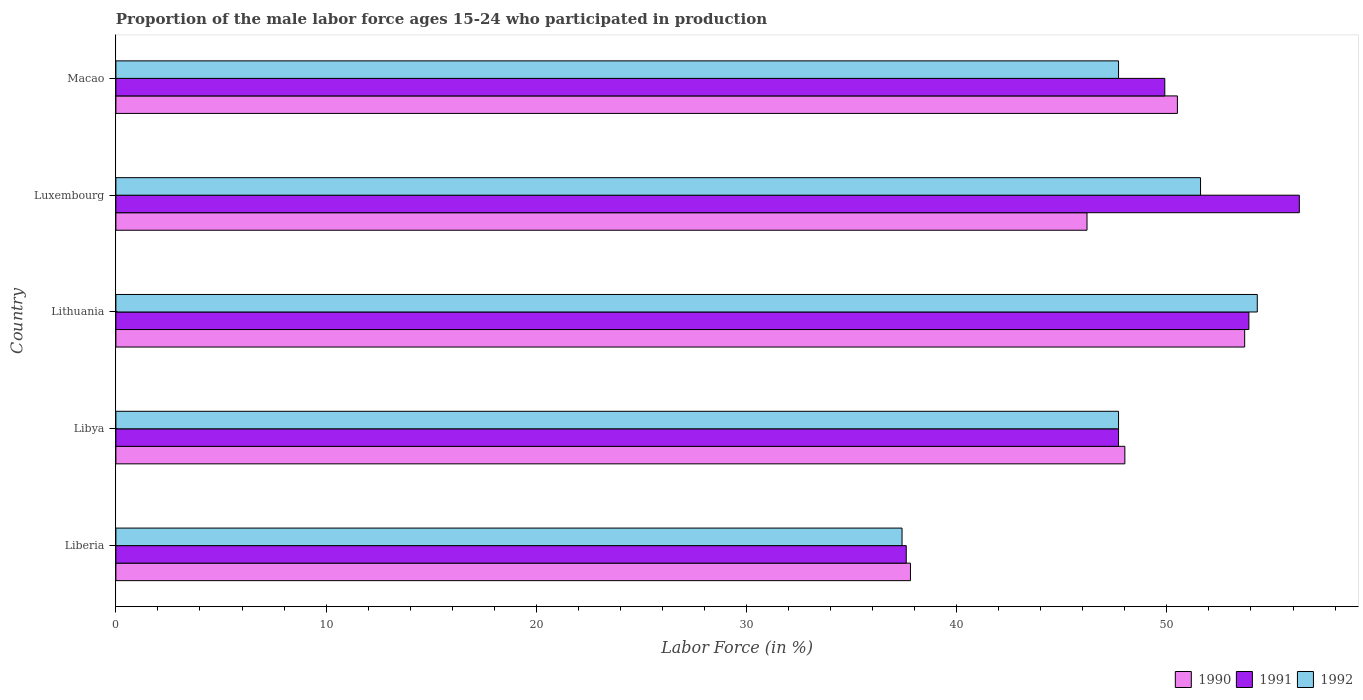Are the number of bars on each tick of the Y-axis equal?
Ensure brevity in your answer.  Yes. How many bars are there on the 5th tick from the bottom?
Offer a very short reply. 3. What is the label of the 1st group of bars from the top?
Provide a succinct answer. Macao. In how many cases, is the number of bars for a given country not equal to the number of legend labels?
Give a very brief answer. 0. What is the proportion of the male labor force who participated in production in 1991 in Luxembourg?
Give a very brief answer. 56.3. Across all countries, what is the maximum proportion of the male labor force who participated in production in 1991?
Your answer should be compact. 56.3. Across all countries, what is the minimum proportion of the male labor force who participated in production in 1990?
Offer a very short reply. 37.8. In which country was the proportion of the male labor force who participated in production in 1992 maximum?
Ensure brevity in your answer.  Lithuania. In which country was the proportion of the male labor force who participated in production in 1990 minimum?
Your response must be concise. Liberia. What is the total proportion of the male labor force who participated in production in 1990 in the graph?
Offer a very short reply. 236.2. What is the difference between the proportion of the male labor force who participated in production in 1990 in Liberia and that in Lithuania?
Your response must be concise. -15.9. What is the difference between the proportion of the male labor force who participated in production in 1991 in Macao and the proportion of the male labor force who participated in production in 1992 in Lithuania?
Provide a succinct answer. -4.4. What is the average proportion of the male labor force who participated in production in 1992 per country?
Keep it short and to the point. 47.74. What is the difference between the proportion of the male labor force who participated in production in 1991 and proportion of the male labor force who participated in production in 1990 in Luxembourg?
Your response must be concise. 10.1. In how many countries, is the proportion of the male labor force who participated in production in 1990 greater than 42 %?
Your answer should be very brief. 4. What is the ratio of the proportion of the male labor force who participated in production in 1990 in Liberia to that in Lithuania?
Provide a succinct answer. 0.7. What is the difference between the highest and the second highest proportion of the male labor force who participated in production in 1991?
Keep it short and to the point. 2.4. What is the difference between the highest and the lowest proportion of the male labor force who participated in production in 1990?
Keep it short and to the point. 15.9. In how many countries, is the proportion of the male labor force who participated in production in 1991 greater than the average proportion of the male labor force who participated in production in 1991 taken over all countries?
Provide a short and direct response. 3. Is the sum of the proportion of the male labor force who participated in production in 1992 in Libya and Lithuania greater than the maximum proportion of the male labor force who participated in production in 1991 across all countries?
Keep it short and to the point. Yes. What does the 2nd bar from the top in Liberia represents?
Make the answer very short. 1991. What does the 3rd bar from the bottom in Lithuania represents?
Your answer should be very brief. 1992. Are all the bars in the graph horizontal?
Give a very brief answer. Yes. How many countries are there in the graph?
Make the answer very short. 5. Does the graph contain any zero values?
Your answer should be very brief. No. Does the graph contain grids?
Make the answer very short. No. Where does the legend appear in the graph?
Provide a short and direct response. Bottom right. How many legend labels are there?
Make the answer very short. 3. What is the title of the graph?
Provide a short and direct response. Proportion of the male labor force ages 15-24 who participated in production. Does "1976" appear as one of the legend labels in the graph?
Ensure brevity in your answer.  No. What is the label or title of the X-axis?
Your answer should be very brief. Labor Force (in %). What is the Labor Force (in %) in 1990 in Liberia?
Your response must be concise. 37.8. What is the Labor Force (in %) of 1991 in Liberia?
Your response must be concise. 37.6. What is the Labor Force (in %) in 1992 in Liberia?
Give a very brief answer. 37.4. What is the Labor Force (in %) of 1990 in Libya?
Your response must be concise. 48. What is the Labor Force (in %) of 1991 in Libya?
Make the answer very short. 47.7. What is the Labor Force (in %) of 1992 in Libya?
Make the answer very short. 47.7. What is the Labor Force (in %) of 1990 in Lithuania?
Make the answer very short. 53.7. What is the Labor Force (in %) in 1991 in Lithuania?
Provide a succinct answer. 53.9. What is the Labor Force (in %) in 1992 in Lithuania?
Provide a short and direct response. 54.3. What is the Labor Force (in %) in 1990 in Luxembourg?
Make the answer very short. 46.2. What is the Labor Force (in %) of 1991 in Luxembourg?
Your response must be concise. 56.3. What is the Labor Force (in %) in 1992 in Luxembourg?
Provide a succinct answer. 51.6. What is the Labor Force (in %) of 1990 in Macao?
Your answer should be very brief. 50.5. What is the Labor Force (in %) of 1991 in Macao?
Offer a terse response. 49.9. What is the Labor Force (in %) of 1992 in Macao?
Offer a terse response. 47.7. Across all countries, what is the maximum Labor Force (in %) in 1990?
Provide a short and direct response. 53.7. Across all countries, what is the maximum Labor Force (in %) in 1991?
Ensure brevity in your answer.  56.3. Across all countries, what is the maximum Labor Force (in %) in 1992?
Provide a succinct answer. 54.3. Across all countries, what is the minimum Labor Force (in %) of 1990?
Give a very brief answer. 37.8. Across all countries, what is the minimum Labor Force (in %) in 1991?
Offer a terse response. 37.6. Across all countries, what is the minimum Labor Force (in %) of 1992?
Your answer should be very brief. 37.4. What is the total Labor Force (in %) of 1990 in the graph?
Make the answer very short. 236.2. What is the total Labor Force (in %) in 1991 in the graph?
Your answer should be very brief. 245.4. What is the total Labor Force (in %) of 1992 in the graph?
Your answer should be compact. 238.7. What is the difference between the Labor Force (in %) in 1990 in Liberia and that in Libya?
Offer a very short reply. -10.2. What is the difference between the Labor Force (in %) in 1992 in Liberia and that in Libya?
Offer a terse response. -10.3. What is the difference between the Labor Force (in %) in 1990 in Liberia and that in Lithuania?
Ensure brevity in your answer.  -15.9. What is the difference between the Labor Force (in %) of 1991 in Liberia and that in Lithuania?
Make the answer very short. -16.3. What is the difference between the Labor Force (in %) of 1992 in Liberia and that in Lithuania?
Ensure brevity in your answer.  -16.9. What is the difference between the Labor Force (in %) in 1990 in Liberia and that in Luxembourg?
Your answer should be compact. -8.4. What is the difference between the Labor Force (in %) of 1991 in Liberia and that in Luxembourg?
Keep it short and to the point. -18.7. What is the difference between the Labor Force (in %) of 1992 in Liberia and that in Luxembourg?
Your answer should be very brief. -14.2. What is the difference between the Labor Force (in %) of 1990 in Liberia and that in Macao?
Offer a terse response. -12.7. What is the difference between the Labor Force (in %) in 1991 in Liberia and that in Macao?
Make the answer very short. -12.3. What is the difference between the Labor Force (in %) of 1990 in Libya and that in Lithuania?
Provide a short and direct response. -5.7. What is the difference between the Labor Force (in %) in 1992 in Libya and that in Lithuania?
Your response must be concise. -6.6. What is the difference between the Labor Force (in %) of 1990 in Libya and that in Luxembourg?
Provide a short and direct response. 1.8. What is the difference between the Labor Force (in %) of 1990 in Libya and that in Macao?
Give a very brief answer. -2.5. What is the difference between the Labor Force (in %) in 1990 in Lithuania and that in Macao?
Your answer should be very brief. 3.2. What is the difference between the Labor Force (in %) in 1991 in Lithuania and that in Macao?
Offer a very short reply. 4. What is the difference between the Labor Force (in %) of 1992 in Lithuania and that in Macao?
Your answer should be compact. 6.6. What is the difference between the Labor Force (in %) of 1991 in Luxembourg and that in Macao?
Your answer should be compact. 6.4. What is the difference between the Labor Force (in %) of 1990 in Liberia and the Labor Force (in %) of 1992 in Libya?
Give a very brief answer. -9.9. What is the difference between the Labor Force (in %) of 1990 in Liberia and the Labor Force (in %) of 1991 in Lithuania?
Offer a terse response. -16.1. What is the difference between the Labor Force (in %) in 1990 in Liberia and the Labor Force (in %) in 1992 in Lithuania?
Your answer should be very brief. -16.5. What is the difference between the Labor Force (in %) in 1991 in Liberia and the Labor Force (in %) in 1992 in Lithuania?
Ensure brevity in your answer.  -16.7. What is the difference between the Labor Force (in %) of 1990 in Liberia and the Labor Force (in %) of 1991 in Luxembourg?
Offer a terse response. -18.5. What is the difference between the Labor Force (in %) of 1990 in Liberia and the Labor Force (in %) of 1991 in Macao?
Your answer should be very brief. -12.1. What is the difference between the Labor Force (in %) in 1991 in Liberia and the Labor Force (in %) in 1992 in Macao?
Make the answer very short. -10.1. What is the difference between the Labor Force (in %) in 1990 in Libya and the Labor Force (in %) in 1991 in Lithuania?
Your answer should be very brief. -5.9. What is the difference between the Labor Force (in %) in 1990 in Libya and the Labor Force (in %) in 1992 in Lithuania?
Your response must be concise. -6.3. What is the difference between the Labor Force (in %) in 1991 in Libya and the Labor Force (in %) in 1992 in Lithuania?
Ensure brevity in your answer.  -6.6. What is the difference between the Labor Force (in %) of 1990 in Libya and the Labor Force (in %) of 1992 in Luxembourg?
Offer a terse response. -3.6. What is the difference between the Labor Force (in %) in 1991 in Libya and the Labor Force (in %) in 1992 in Luxembourg?
Your answer should be compact. -3.9. What is the difference between the Labor Force (in %) of 1990 in Libya and the Labor Force (in %) of 1991 in Macao?
Provide a succinct answer. -1.9. What is the difference between the Labor Force (in %) of 1991 in Libya and the Labor Force (in %) of 1992 in Macao?
Ensure brevity in your answer.  0. What is the difference between the Labor Force (in %) in 1990 in Lithuania and the Labor Force (in %) in 1991 in Luxembourg?
Your answer should be very brief. -2.6. What is the difference between the Labor Force (in %) of 1990 in Lithuania and the Labor Force (in %) of 1992 in Luxembourg?
Give a very brief answer. 2.1. What is the difference between the Labor Force (in %) of 1991 in Lithuania and the Labor Force (in %) of 1992 in Luxembourg?
Your answer should be very brief. 2.3. What is the difference between the Labor Force (in %) of 1990 in Lithuania and the Labor Force (in %) of 1991 in Macao?
Give a very brief answer. 3.8. What is the average Labor Force (in %) of 1990 per country?
Your response must be concise. 47.24. What is the average Labor Force (in %) of 1991 per country?
Your response must be concise. 49.08. What is the average Labor Force (in %) in 1992 per country?
Ensure brevity in your answer.  47.74. What is the difference between the Labor Force (in %) of 1991 and Labor Force (in %) of 1992 in Liberia?
Offer a terse response. 0.2. What is the difference between the Labor Force (in %) of 1991 and Labor Force (in %) of 1992 in Libya?
Offer a very short reply. 0. What is the difference between the Labor Force (in %) in 1991 and Labor Force (in %) in 1992 in Lithuania?
Make the answer very short. -0.4. What is the difference between the Labor Force (in %) in 1990 and Labor Force (in %) in 1992 in Luxembourg?
Offer a very short reply. -5.4. What is the difference between the Labor Force (in %) of 1991 and Labor Force (in %) of 1992 in Luxembourg?
Give a very brief answer. 4.7. What is the difference between the Labor Force (in %) in 1990 and Labor Force (in %) in 1991 in Macao?
Keep it short and to the point. 0.6. What is the difference between the Labor Force (in %) of 1990 and Labor Force (in %) of 1992 in Macao?
Make the answer very short. 2.8. What is the difference between the Labor Force (in %) of 1991 and Labor Force (in %) of 1992 in Macao?
Give a very brief answer. 2.2. What is the ratio of the Labor Force (in %) of 1990 in Liberia to that in Libya?
Keep it short and to the point. 0.79. What is the ratio of the Labor Force (in %) of 1991 in Liberia to that in Libya?
Provide a succinct answer. 0.79. What is the ratio of the Labor Force (in %) in 1992 in Liberia to that in Libya?
Offer a very short reply. 0.78. What is the ratio of the Labor Force (in %) of 1990 in Liberia to that in Lithuania?
Make the answer very short. 0.7. What is the ratio of the Labor Force (in %) in 1991 in Liberia to that in Lithuania?
Ensure brevity in your answer.  0.7. What is the ratio of the Labor Force (in %) of 1992 in Liberia to that in Lithuania?
Give a very brief answer. 0.69. What is the ratio of the Labor Force (in %) of 1990 in Liberia to that in Luxembourg?
Your response must be concise. 0.82. What is the ratio of the Labor Force (in %) in 1991 in Liberia to that in Luxembourg?
Your answer should be very brief. 0.67. What is the ratio of the Labor Force (in %) in 1992 in Liberia to that in Luxembourg?
Offer a very short reply. 0.72. What is the ratio of the Labor Force (in %) in 1990 in Liberia to that in Macao?
Keep it short and to the point. 0.75. What is the ratio of the Labor Force (in %) in 1991 in Liberia to that in Macao?
Give a very brief answer. 0.75. What is the ratio of the Labor Force (in %) in 1992 in Liberia to that in Macao?
Your answer should be compact. 0.78. What is the ratio of the Labor Force (in %) in 1990 in Libya to that in Lithuania?
Keep it short and to the point. 0.89. What is the ratio of the Labor Force (in %) of 1991 in Libya to that in Lithuania?
Offer a terse response. 0.89. What is the ratio of the Labor Force (in %) in 1992 in Libya to that in Lithuania?
Provide a succinct answer. 0.88. What is the ratio of the Labor Force (in %) of 1990 in Libya to that in Luxembourg?
Give a very brief answer. 1.04. What is the ratio of the Labor Force (in %) in 1991 in Libya to that in Luxembourg?
Provide a succinct answer. 0.85. What is the ratio of the Labor Force (in %) in 1992 in Libya to that in Luxembourg?
Give a very brief answer. 0.92. What is the ratio of the Labor Force (in %) of 1990 in Libya to that in Macao?
Your answer should be compact. 0.95. What is the ratio of the Labor Force (in %) of 1991 in Libya to that in Macao?
Offer a very short reply. 0.96. What is the ratio of the Labor Force (in %) in 1990 in Lithuania to that in Luxembourg?
Your answer should be compact. 1.16. What is the ratio of the Labor Force (in %) in 1991 in Lithuania to that in Luxembourg?
Provide a short and direct response. 0.96. What is the ratio of the Labor Force (in %) in 1992 in Lithuania to that in Luxembourg?
Keep it short and to the point. 1.05. What is the ratio of the Labor Force (in %) in 1990 in Lithuania to that in Macao?
Make the answer very short. 1.06. What is the ratio of the Labor Force (in %) of 1991 in Lithuania to that in Macao?
Provide a short and direct response. 1.08. What is the ratio of the Labor Force (in %) of 1992 in Lithuania to that in Macao?
Offer a terse response. 1.14. What is the ratio of the Labor Force (in %) in 1990 in Luxembourg to that in Macao?
Provide a short and direct response. 0.91. What is the ratio of the Labor Force (in %) in 1991 in Luxembourg to that in Macao?
Offer a very short reply. 1.13. What is the ratio of the Labor Force (in %) in 1992 in Luxembourg to that in Macao?
Offer a very short reply. 1.08. What is the difference between the highest and the second highest Labor Force (in %) of 1990?
Your answer should be compact. 3.2. What is the difference between the highest and the second highest Labor Force (in %) in 1991?
Keep it short and to the point. 2.4. What is the difference between the highest and the second highest Labor Force (in %) in 1992?
Ensure brevity in your answer.  2.7. 